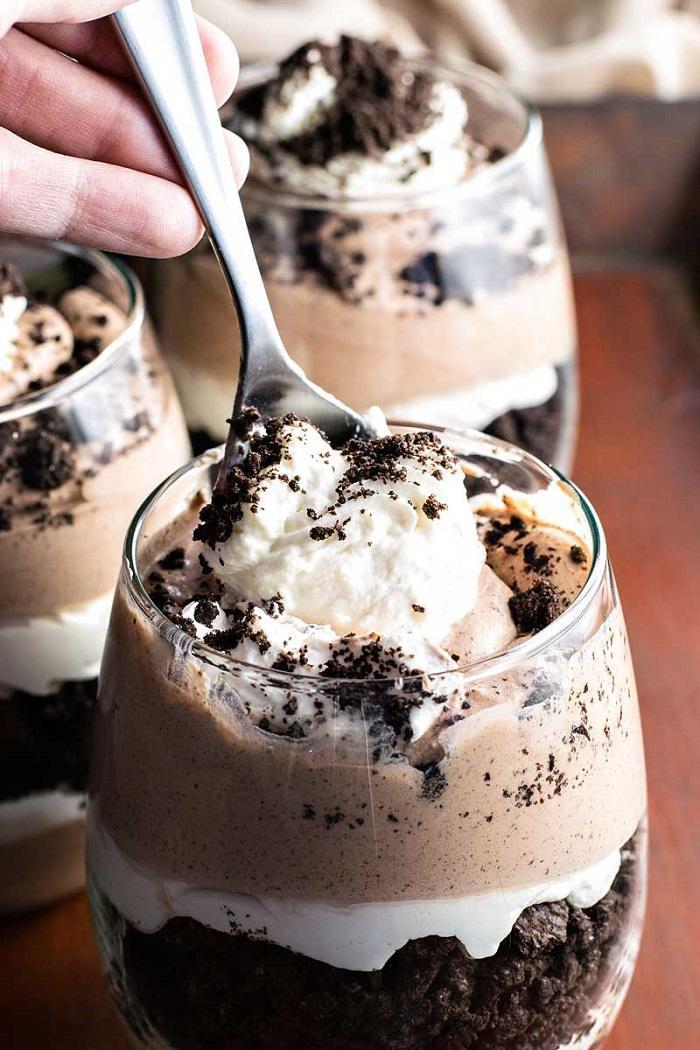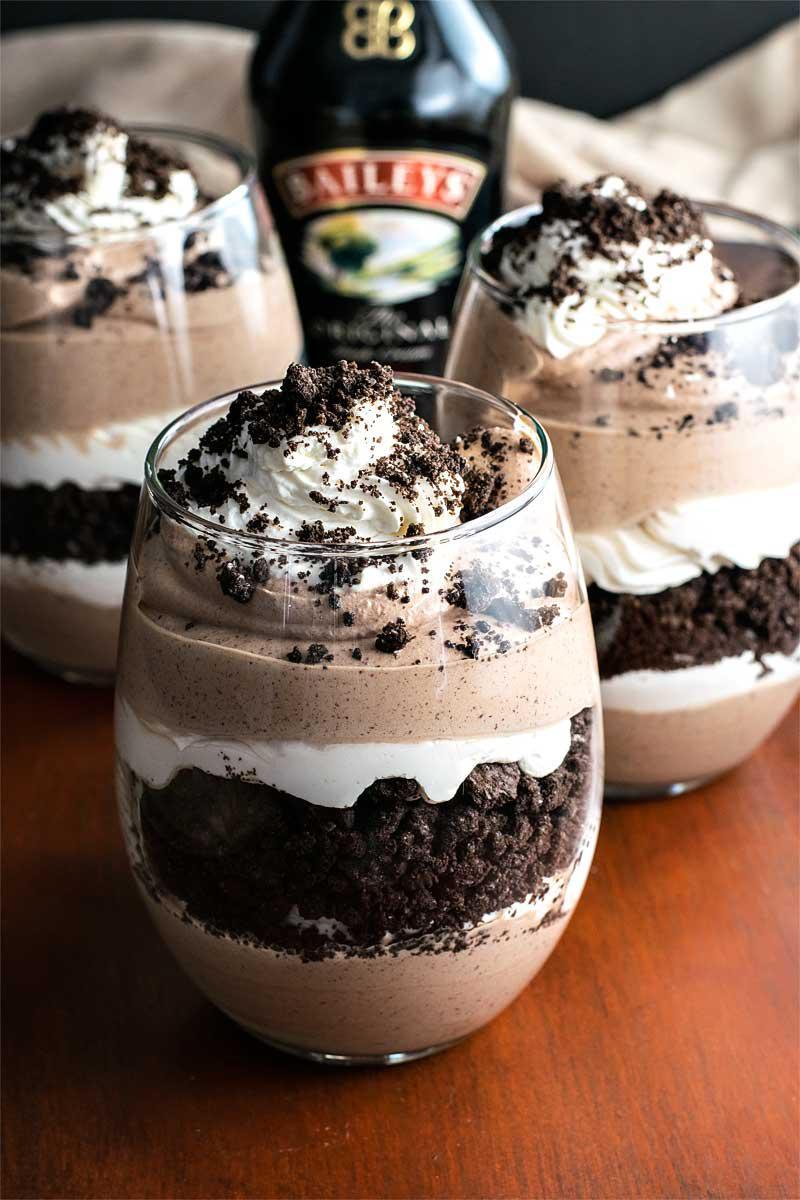The first image is the image on the left, the second image is the image on the right. Considering the images on both sides, is "In both pictures on the right side, there are three glasses the contain layers of chocolate and whipped cream topped with cookie crumbles." valid? Answer yes or no. Yes. The first image is the image on the left, the second image is the image on the right. Considering the images on both sides, is "# glasses are filed with cream and fruit." valid? Answer yes or no. No. 